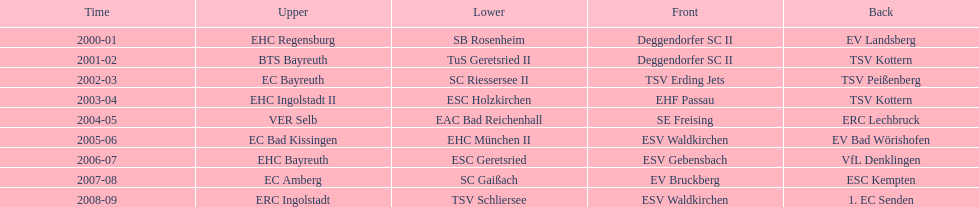The last team to win the west? 1. EC Senden. 